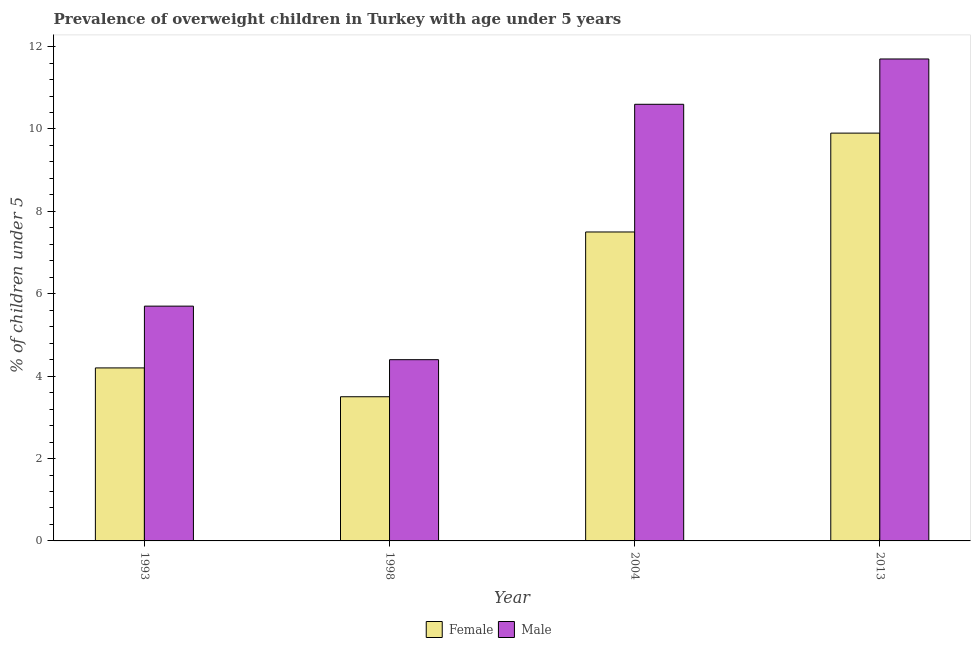How many groups of bars are there?
Keep it short and to the point. 4. Are the number of bars per tick equal to the number of legend labels?
Your answer should be very brief. Yes. How many bars are there on the 2nd tick from the left?
Keep it short and to the point. 2. What is the label of the 4th group of bars from the left?
Keep it short and to the point. 2013. What is the percentage of obese female children in 2013?
Provide a short and direct response. 9.9. Across all years, what is the maximum percentage of obese female children?
Provide a succinct answer. 9.9. Across all years, what is the minimum percentage of obese female children?
Your answer should be very brief. 3.5. In which year was the percentage of obese male children maximum?
Provide a succinct answer. 2013. In which year was the percentage of obese female children minimum?
Offer a very short reply. 1998. What is the total percentage of obese male children in the graph?
Provide a succinct answer. 32.4. What is the difference between the percentage of obese female children in 1998 and that in 2013?
Offer a terse response. -6.4. What is the difference between the percentage of obese male children in 2013 and the percentage of obese female children in 1993?
Your response must be concise. 6. What is the average percentage of obese male children per year?
Offer a terse response. 8.1. In the year 2004, what is the difference between the percentage of obese female children and percentage of obese male children?
Make the answer very short. 0. In how many years, is the percentage of obese male children greater than 3.2 %?
Your answer should be compact. 4. What is the ratio of the percentage of obese female children in 2004 to that in 2013?
Your answer should be very brief. 0.76. Is the difference between the percentage of obese female children in 1993 and 2004 greater than the difference between the percentage of obese male children in 1993 and 2004?
Your answer should be very brief. No. What is the difference between the highest and the second highest percentage of obese female children?
Your response must be concise. 2.4. What is the difference between the highest and the lowest percentage of obese male children?
Make the answer very short. 7.3. What does the 1st bar from the left in 2004 represents?
Provide a succinct answer. Female. Are the values on the major ticks of Y-axis written in scientific E-notation?
Make the answer very short. No. Does the graph contain any zero values?
Ensure brevity in your answer.  No. Does the graph contain grids?
Offer a terse response. No. Where does the legend appear in the graph?
Offer a very short reply. Bottom center. How many legend labels are there?
Provide a succinct answer. 2. How are the legend labels stacked?
Make the answer very short. Horizontal. What is the title of the graph?
Ensure brevity in your answer.  Prevalence of overweight children in Turkey with age under 5 years. Does "Electricity and heat production" appear as one of the legend labels in the graph?
Ensure brevity in your answer.  No. What is the label or title of the X-axis?
Offer a very short reply. Year. What is the label or title of the Y-axis?
Make the answer very short.  % of children under 5. What is the  % of children under 5 of Female in 1993?
Offer a terse response. 4.2. What is the  % of children under 5 in Male in 1993?
Your answer should be very brief. 5.7. What is the  % of children under 5 in Female in 1998?
Your response must be concise. 3.5. What is the  % of children under 5 of Male in 1998?
Keep it short and to the point. 4.4. What is the  % of children under 5 in Male in 2004?
Keep it short and to the point. 10.6. What is the  % of children under 5 of Female in 2013?
Offer a very short reply. 9.9. What is the  % of children under 5 in Male in 2013?
Offer a very short reply. 11.7. Across all years, what is the maximum  % of children under 5 of Female?
Provide a short and direct response. 9.9. Across all years, what is the maximum  % of children under 5 of Male?
Give a very brief answer. 11.7. Across all years, what is the minimum  % of children under 5 in Female?
Ensure brevity in your answer.  3.5. Across all years, what is the minimum  % of children under 5 of Male?
Your answer should be very brief. 4.4. What is the total  % of children under 5 of Female in the graph?
Offer a very short reply. 25.1. What is the total  % of children under 5 in Male in the graph?
Your answer should be very brief. 32.4. What is the difference between the  % of children under 5 of Male in 1993 and that in 2013?
Offer a terse response. -6. What is the difference between the  % of children under 5 in Female in 1998 and that in 2004?
Offer a very short reply. -4. What is the difference between the  % of children under 5 of Male in 1998 and that in 2004?
Provide a short and direct response. -6.2. What is the difference between the  % of children under 5 in Female in 1993 and the  % of children under 5 in Male in 2004?
Your answer should be very brief. -6.4. What is the difference between the  % of children under 5 in Female in 1998 and the  % of children under 5 in Male in 2004?
Ensure brevity in your answer.  -7.1. What is the difference between the  % of children under 5 of Female in 1998 and the  % of children under 5 of Male in 2013?
Your answer should be compact. -8.2. What is the difference between the  % of children under 5 of Female in 2004 and the  % of children under 5 of Male in 2013?
Provide a short and direct response. -4.2. What is the average  % of children under 5 of Female per year?
Provide a succinct answer. 6.28. What is the average  % of children under 5 in Male per year?
Provide a succinct answer. 8.1. In the year 1993, what is the difference between the  % of children under 5 of Female and  % of children under 5 of Male?
Make the answer very short. -1.5. In the year 1998, what is the difference between the  % of children under 5 in Female and  % of children under 5 in Male?
Give a very brief answer. -0.9. What is the ratio of the  % of children under 5 of Female in 1993 to that in 1998?
Keep it short and to the point. 1.2. What is the ratio of the  % of children under 5 in Male in 1993 to that in 1998?
Your answer should be compact. 1.3. What is the ratio of the  % of children under 5 of Female in 1993 to that in 2004?
Give a very brief answer. 0.56. What is the ratio of the  % of children under 5 in Male in 1993 to that in 2004?
Your answer should be very brief. 0.54. What is the ratio of the  % of children under 5 of Female in 1993 to that in 2013?
Make the answer very short. 0.42. What is the ratio of the  % of children under 5 in Male in 1993 to that in 2013?
Make the answer very short. 0.49. What is the ratio of the  % of children under 5 of Female in 1998 to that in 2004?
Offer a terse response. 0.47. What is the ratio of the  % of children under 5 of Male in 1998 to that in 2004?
Provide a succinct answer. 0.42. What is the ratio of the  % of children under 5 of Female in 1998 to that in 2013?
Make the answer very short. 0.35. What is the ratio of the  % of children under 5 in Male in 1998 to that in 2013?
Make the answer very short. 0.38. What is the ratio of the  % of children under 5 in Female in 2004 to that in 2013?
Offer a terse response. 0.76. What is the ratio of the  % of children under 5 of Male in 2004 to that in 2013?
Give a very brief answer. 0.91. 